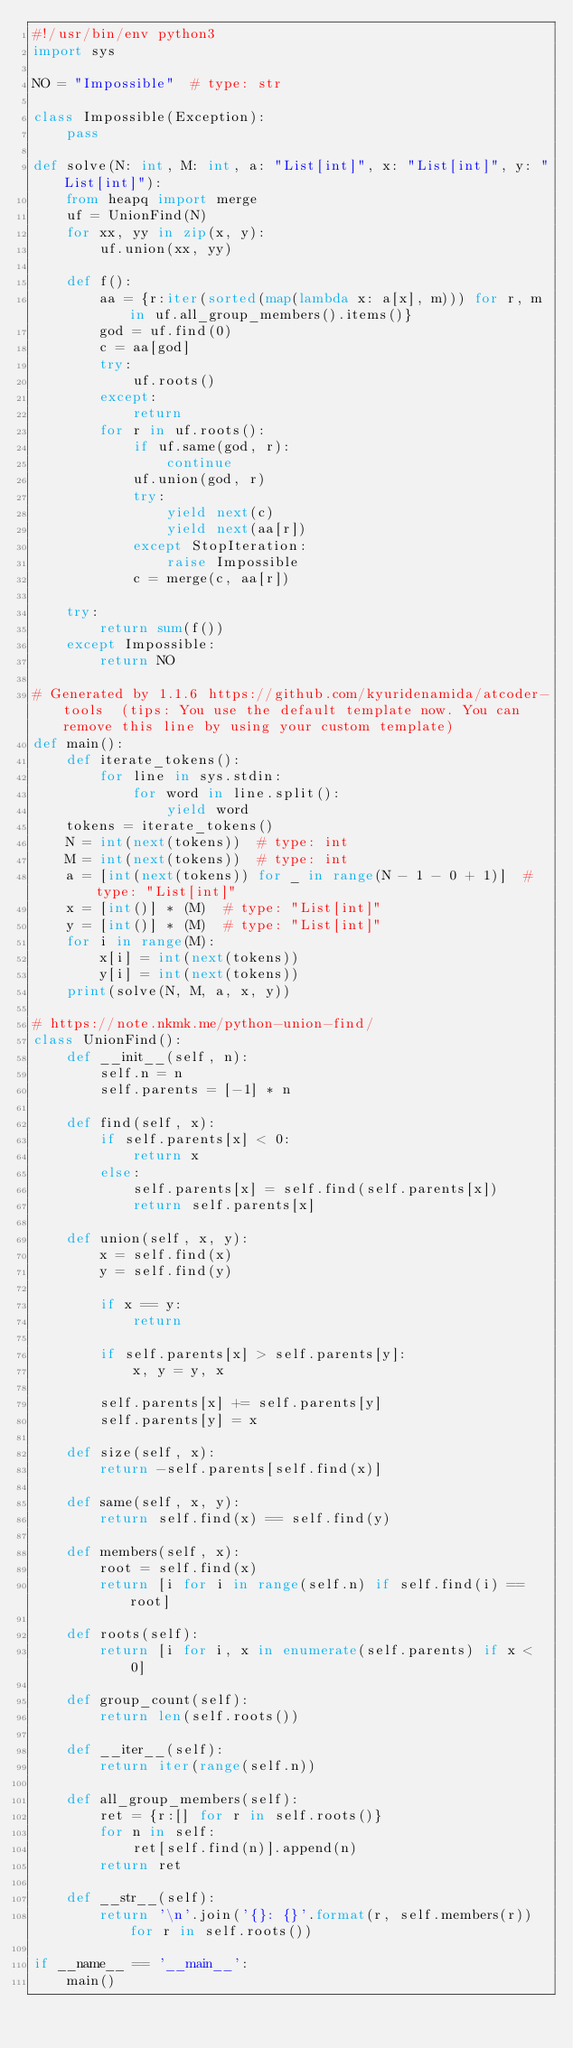Convert code to text. <code><loc_0><loc_0><loc_500><loc_500><_Python_>#!/usr/bin/env python3
import sys

NO = "Impossible"  # type: str

class Impossible(Exception):
    pass

def solve(N: int, M: int, a: "List[int]", x: "List[int]", y: "List[int]"):
    from heapq import merge
    uf = UnionFind(N)
    for xx, yy in zip(x, y):
        uf.union(xx, yy)

    def f():
        aa = {r:iter(sorted(map(lambda x: a[x], m))) for r, m in uf.all_group_members().items()}
        god = uf.find(0)
        c = aa[god]
        try:
            uf.roots()
        except:
            return
        for r in uf.roots():
            if uf.same(god, r):
                continue
            uf.union(god, r)
            try:
                yield next(c)
                yield next(aa[r])
            except StopIteration:
                raise Impossible
            c = merge(c, aa[r])

    try:
        return sum(f())
    except Impossible:
        return NO

# Generated by 1.1.6 https://github.com/kyuridenamida/atcoder-tools  (tips: You use the default template now. You can remove this line by using your custom template)
def main():
    def iterate_tokens():
        for line in sys.stdin:
            for word in line.split():
                yield word
    tokens = iterate_tokens()
    N = int(next(tokens))  # type: int
    M = int(next(tokens))  # type: int
    a = [int(next(tokens)) for _ in range(N - 1 - 0 + 1)]  # type: "List[int]"
    x = [int()] * (M)  # type: "List[int]"
    y = [int()] * (M)  # type: "List[int]"
    for i in range(M):
        x[i] = int(next(tokens))
        y[i] = int(next(tokens))
    print(solve(N, M, a, x, y))

# https://note.nkmk.me/python-union-find/
class UnionFind():
    def __init__(self, n):
        self.n = n
        self.parents = [-1] * n
        
    def find(self, x):
        if self.parents[x] < 0:
            return x
        else:
            self.parents[x] = self.find(self.parents[x])
            return self.parents[x]
    
    def union(self, x, y):
        x = self.find(x)
        y = self.find(y)
        
        if x == y:
            return
        
        if self.parents[x] > self.parents[y]:
            x, y = y, x
        
        self.parents[x] += self.parents[y]
        self.parents[y] = x
    
    def size(self, x):
        return -self.parents[self.find(x)]
        
    def same(self, x, y):
        return self.find(x) == self.find(y)
    
    def members(self, x):
        root = self.find(x)
        return [i for i in range(self.n) if self.find(i) == root]
    
    def roots(self):
        return [i for i, x in enumerate(self.parents) if x < 0]
 
    def group_count(self):
        return len(self.roots())

    def __iter__(self):
        return iter(range(self.n))
    
    def all_group_members(self):
        ret = {r:[] for r in self.roots()}
        for n in self:
            ret[self.find(n)].append(n)
        return ret
    
    def __str__(self):
        return '\n'.join('{}: {}'.format(r, self.members(r)) for r in self.roots())

if __name__ == '__main__':
    main()
</code> 